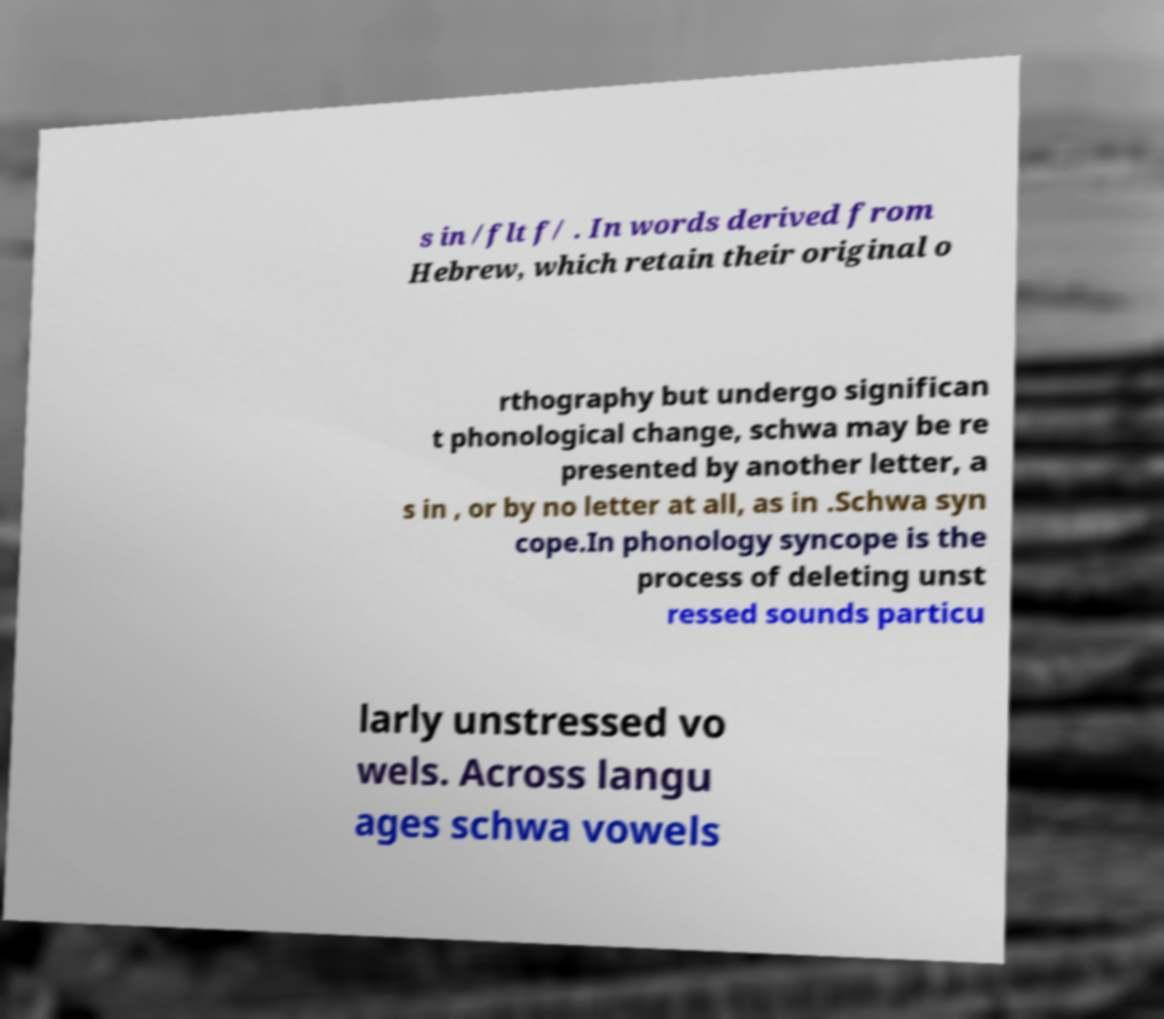For documentation purposes, I need the text within this image transcribed. Could you provide that? s in /flt f/ . In words derived from Hebrew, which retain their original o rthography but undergo significan t phonological change, schwa may be re presented by another letter, a s in , or by no letter at all, as in .Schwa syn cope.In phonology syncope is the process of deleting unst ressed sounds particu larly unstressed vo wels. Across langu ages schwa vowels 